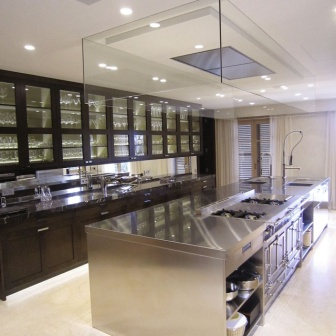Imagine this kitchen as a set for a cooking show. What kind of features would make it television-ready? Transforming this kitchen into a set for a cooking show would require a few enhancements to emphasize its functionality and aesthetic appeal. Additional overhead cameras would be installed to give viewers clear views of the cooking processes on the island. Enhanced lighting, including softbox lights, would ensure that the chef and the food are always well-illuminated and camera-ready.

Under-shelf LED lights could be added for accent lighting, helping to highlight the kitchen’s features and create a visually appealing backdrop. Microphones could be discreetly placed to capture crisp audio of sizzles, chops, and the host's commentary without interfering with the show’s visual elements. Finally, adding some stylish, functional kitchen props like colorful cookware, neatly arranged herbs, and fresh ingredients could make the set look more lively and inviting while still allowing the island to be the focal point of the show. How would the kitchen's design influence the flow of a cooking show? The kitchen’s open design and strategic layout would significantly influence the smooth flow of a cooking show. The large central island offers ample workspace for the chef to demonstrate cutting, mixing, and cooking without needing to move around too often. With stovetops on either side and a centrally placed sink, the chef can seamlessly transition between different stages of the cooking process.

The cabinets with glass doors can be aesthetically pleasing, showcasing neatly organized utensils, spices, and ingredients, adding an element of visual interest for viewers. The natural light from the windows would enhance the show's visual quality, making it more engaging for viewers. The overall symmetry and tidy arrangement of the kitchen also add to its appeal, making it a pleasant backdrop for filming while ensuring that the cooking process is efficient and visually compelling. 